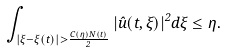<formula> <loc_0><loc_0><loc_500><loc_500>\int _ { | \xi - \xi ( t ) | > \frac { C ( \eta ) N ( t ) } { 2 } } | \hat { u } ( t , \xi ) | ^ { 2 } d \xi \leq \eta .</formula> 